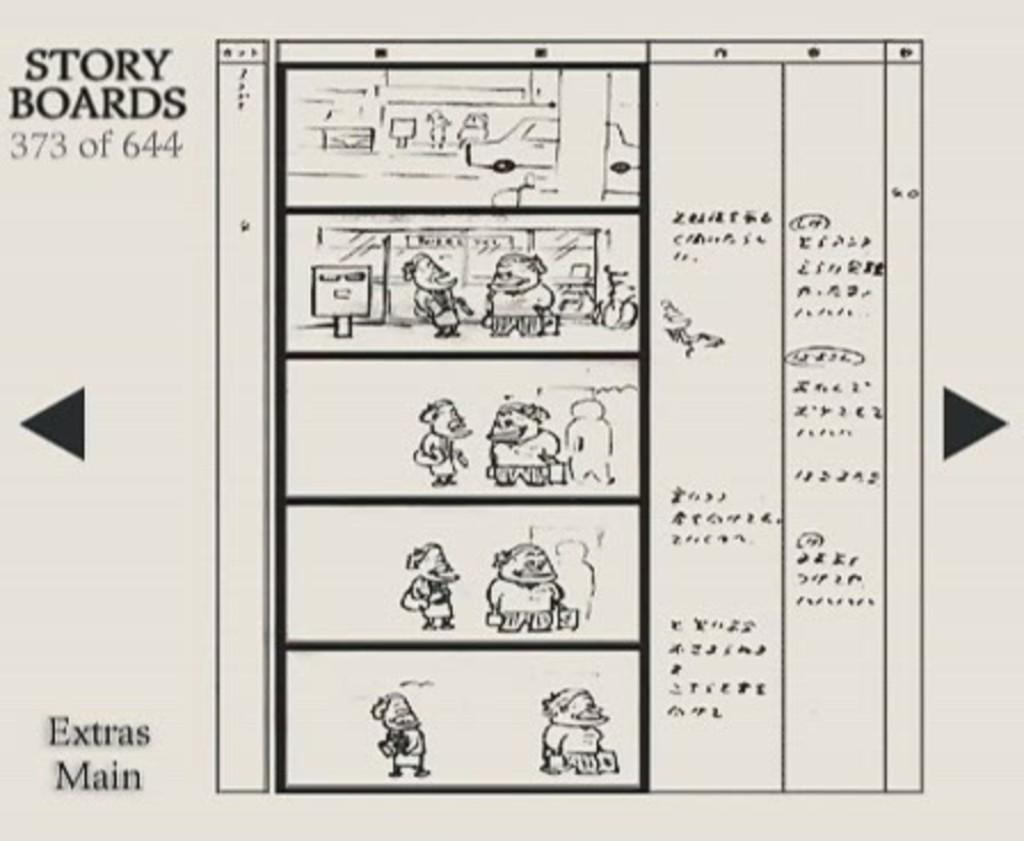What is the main subject of the drawing in the image? The drawing depicts a group of persons. What additional feature can be observed in the drawing? There is text present in the drawing. What type of cable is being used by the authority in the drawing? There is no cable or authority present in the drawing; it only depicts a group of persons and text. 